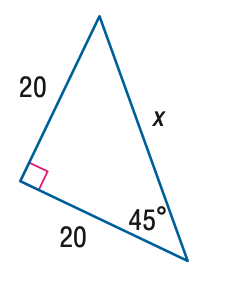Question: Find x.
Choices:
A. 10 \sqrt { 2 }
B. 20 \sqrt { 2 }
C. 20 \sqrt { 3 }
D. 40
Answer with the letter. Answer: B 